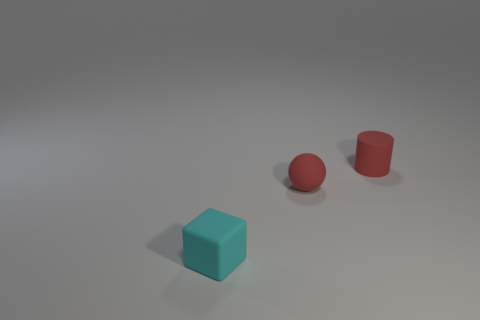Are there any red things that have the same size as the red ball?
Provide a succinct answer. Yes. There is a sphere that is in front of the matte cylinder; is it the same color as the small cylinder?
Your answer should be compact. Yes. What number of other tiny shiny spheres have the same color as the sphere?
Provide a succinct answer. 0. How many tiny green objects are there?
Make the answer very short. 0. How many other small cubes are made of the same material as the cyan cube?
Make the answer very short. 0. Is there any other thing that has the same shape as the tiny cyan rubber object?
Ensure brevity in your answer.  No. There is a tiny object that is right of the small red rubber ball; does it have the same color as the rubber ball that is in front of the small cylinder?
Offer a very short reply. Yes. Are there more red matte objects that are on the right side of the tiny red sphere than large blocks?
Make the answer very short. Yes. How many tiny things are both in front of the red matte cylinder and right of the tiny block?
Your answer should be very brief. 1. Is the tiny red thing in front of the red matte cylinder made of the same material as the tiny cylinder?
Make the answer very short. Yes. 